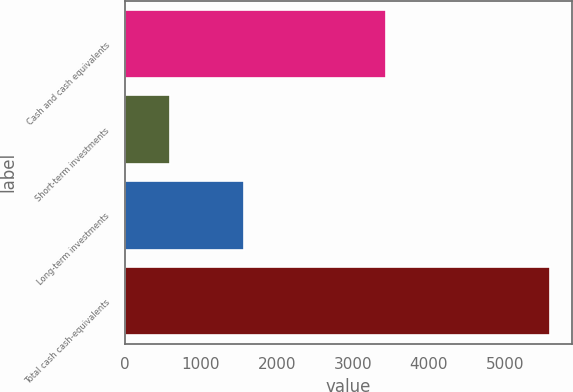Convert chart. <chart><loc_0><loc_0><loc_500><loc_500><bar_chart><fcel>Cash and cash equivalents<fcel>Short-term investments<fcel>Long-term investments<fcel>Total cash cash-equivalents<nl><fcel>3440<fcel>590<fcel>1568<fcel>5598<nl></chart> 